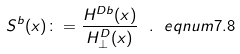Convert formula to latex. <formula><loc_0><loc_0><loc_500><loc_500>S ^ { b } ( x ) \colon = \frac { H ^ { D b } ( x ) } { H ^ { D } _ { \perp } ( x ) } \ . \ e q n u m { 7 . 8 }</formula> 